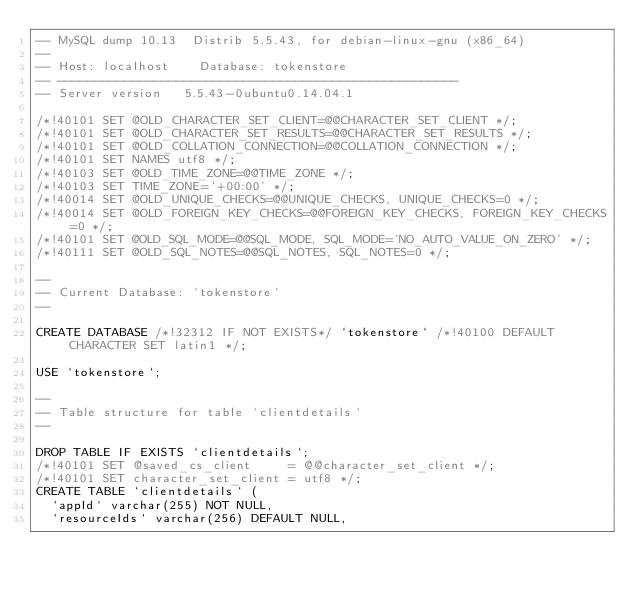Convert code to text. <code><loc_0><loc_0><loc_500><loc_500><_SQL_>-- MySQL dump 10.13  Distrib 5.5.43, for debian-linux-gnu (x86_64)
--
-- Host: localhost    Database: tokenstore
-- ------------------------------------------------------
-- Server version	5.5.43-0ubuntu0.14.04.1

/*!40101 SET @OLD_CHARACTER_SET_CLIENT=@@CHARACTER_SET_CLIENT */;
/*!40101 SET @OLD_CHARACTER_SET_RESULTS=@@CHARACTER_SET_RESULTS */;
/*!40101 SET @OLD_COLLATION_CONNECTION=@@COLLATION_CONNECTION */;
/*!40101 SET NAMES utf8 */;
/*!40103 SET @OLD_TIME_ZONE=@@TIME_ZONE */;
/*!40103 SET TIME_ZONE='+00:00' */;
/*!40014 SET @OLD_UNIQUE_CHECKS=@@UNIQUE_CHECKS, UNIQUE_CHECKS=0 */;
/*!40014 SET @OLD_FOREIGN_KEY_CHECKS=@@FOREIGN_KEY_CHECKS, FOREIGN_KEY_CHECKS=0 */;
/*!40101 SET @OLD_SQL_MODE=@@SQL_MODE, SQL_MODE='NO_AUTO_VALUE_ON_ZERO' */;
/*!40111 SET @OLD_SQL_NOTES=@@SQL_NOTES, SQL_NOTES=0 */;

--
-- Current Database: `tokenstore`
--

CREATE DATABASE /*!32312 IF NOT EXISTS*/ `tokenstore` /*!40100 DEFAULT CHARACTER SET latin1 */;

USE `tokenstore`;

--
-- Table structure for table `clientdetails`
--

DROP TABLE IF EXISTS `clientdetails`;
/*!40101 SET @saved_cs_client     = @@character_set_client */;
/*!40101 SET character_set_client = utf8 */;
CREATE TABLE `clientdetails` (
  `appId` varchar(255) NOT NULL,
  `resourceIds` varchar(256) DEFAULT NULL,</code> 